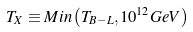Convert formula to latex. <formula><loc_0><loc_0><loc_500><loc_500>T _ { X } \equiv M i n \left ( T _ { B - L } , 1 0 ^ { 1 2 } G e V \right )</formula> 